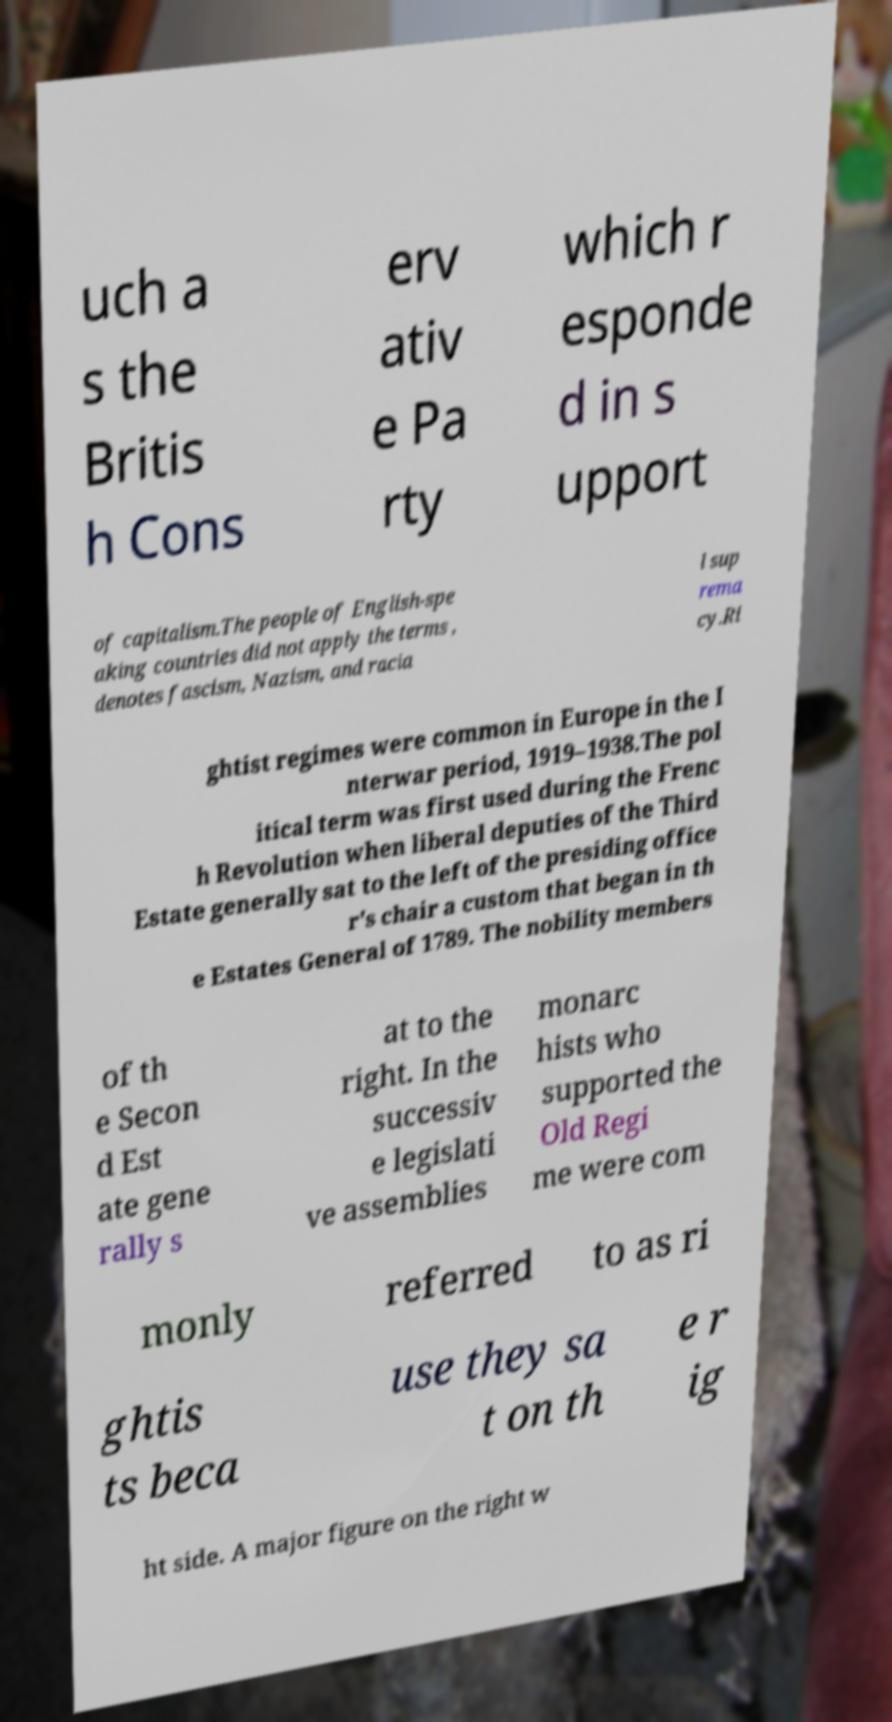There's text embedded in this image that I need extracted. Can you transcribe it verbatim? uch a s the Britis h Cons erv ativ e Pa rty which r esponde d in s upport of capitalism.The people of English-spe aking countries did not apply the terms , denotes fascism, Nazism, and racia l sup rema cy.Ri ghtist regimes were common in Europe in the I nterwar period, 1919–1938.The pol itical term was first used during the Frenc h Revolution when liberal deputies of the Third Estate generally sat to the left of the presiding office r's chair a custom that began in th e Estates General of 1789. The nobility members of th e Secon d Est ate gene rally s at to the right. In the successiv e legislati ve assemblies monarc hists who supported the Old Regi me were com monly referred to as ri ghtis ts beca use they sa t on th e r ig ht side. A major figure on the right w 